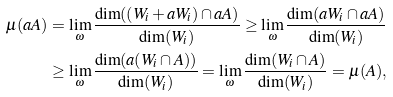<formula> <loc_0><loc_0><loc_500><loc_500>\mu ( a A ) & = \lim _ { \omega } \frac { \dim ( ( W _ { i } + a W _ { i } ) \cap a A ) } { \dim ( W _ { i } ) } \geq \lim _ { \omega } \frac { \dim ( a W _ { i } \cap a A ) } { \dim ( W _ { i } ) } \\ & \geq \lim _ { \omega } \frac { \dim ( a ( W _ { i } \cap A ) ) } { \dim ( W _ { i } ) } = \lim _ { \omega } \frac { \dim ( W _ { i } \cap A ) } { \dim ( W _ { i } ) } = \mu ( A ) ,</formula> 